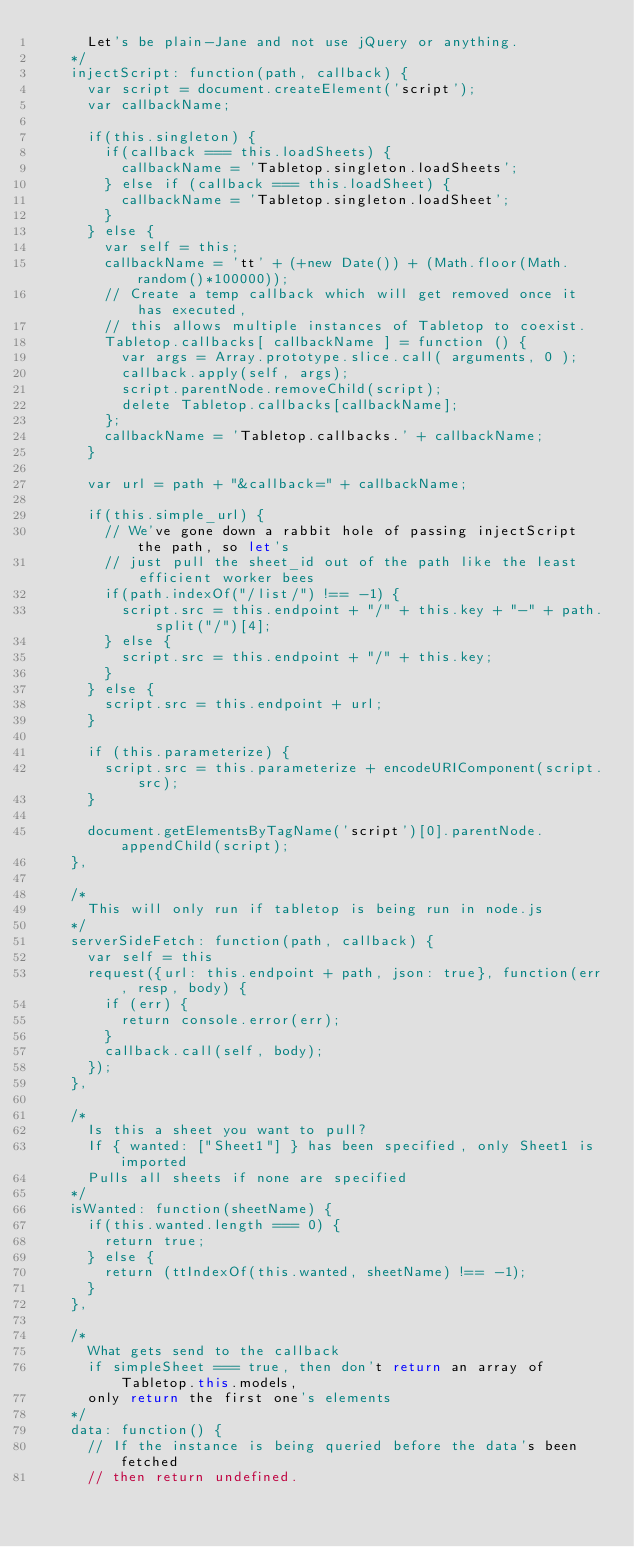<code> <loc_0><loc_0><loc_500><loc_500><_JavaScript_>      Let's be plain-Jane and not use jQuery or anything.
    */
    injectScript: function(path, callback) {
      var script = document.createElement('script');
      var callbackName;
      
      if(this.singleton) {
        if(callback === this.loadSheets) {
          callbackName = 'Tabletop.singleton.loadSheets';
        } else if (callback === this.loadSheet) {
          callbackName = 'Tabletop.singleton.loadSheet';
        }
      } else {
        var self = this;
        callbackName = 'tt' + (+new Date()) + (Math.floor(Math.random()*100000));
        // Create a temp callback which will get removed once it has executed,
        // this allows multiple instances of Tabletop to coexist.
        Tabletop.callbacks[ callbackName ] = function () {
          var args = Array.prototype.slice.call( arguments, 0 );
          callback.apply(self, args);
          script.parentNode.removeChild(script);
          delete Tabletop.callbacks[callbackName];
        };
        callbackName = 'Tabletop.callbacks.' + callbackName;
      }
      
      var url = path + "&callback=" + callbackName;
      
      if(this.simple_url) {
        // We've gone down a rabbit hole of passing injectScript the path, so let's
        // just pull the sheet_id out of the path like the least efficient worker bees
        if(path.indexOf("/list/") !== -1) {
          script.src = this.endpoint + "/" + this.key + "-" + path.split("/")[4];
        } else {
          script.src = this.endpoint + "/" + this.key;
        }
      } else {
        script.src = this.endpoint + url;
      }
      
      if (this.parameterize) {
        script.src = this.parameterize + encodeURIComponent(script.src);
      }
      
      document.getElementsByTagName('script')[0].parentNode.appendChild(script);
    },
    
    /* 
      This will only run if tabletop is being run in node.js
    */
    serverSideFetch: function(path, callback) {
      var self = this
      request({url: this.endpoint + path, json: true}, function(err, resp, body) {
        if (err) {
          return console.error(err);
        }
        callback.call(self, body);
      });
    },

    /* 
      Is this a sheet you want to pull?
      If { wanted: ["Sheet1"] } has been specified, only Sheet1 is imported
      Pulls all sheets if none are specified
    */
    isWanted: function(sheetName) {
      if(this.wanted.length === 0) {
        return true;
      } else {
        return (ttIndexOf(this.wanted, sheetName) !== -1);
      }
    },
    
    /*
      What gets send to the callback
      if simpleSheet === true, then don't return an array of Tabletop.this.models,
      only return the first one's elements
    */
    data: function() {
      // If the instance is being queried before the data's been fetched
      // then return undefined.</code> 